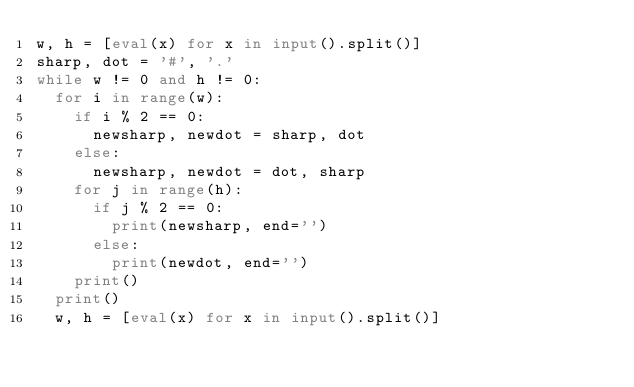<code> <loc_0><loc_0><loc_500><loc_500><_Python_>w, h = [eval(x) for x in input().split()]
sharp, dot = '#', '.'
while w != 0 and h != 0:
  for i in range(w):
    if i % 2 == 0:
      newsharp, newdot = sharp, dot
    else:
      newsharp, newdot = dot, sharp
    for j in range(h):
      if j % 2 == 0:
        print(newsharp, end='')
      else:
        print(newdot, end='')
    print()
  print()
  w, h = [eval(x) for x in input().split()]

</code> 